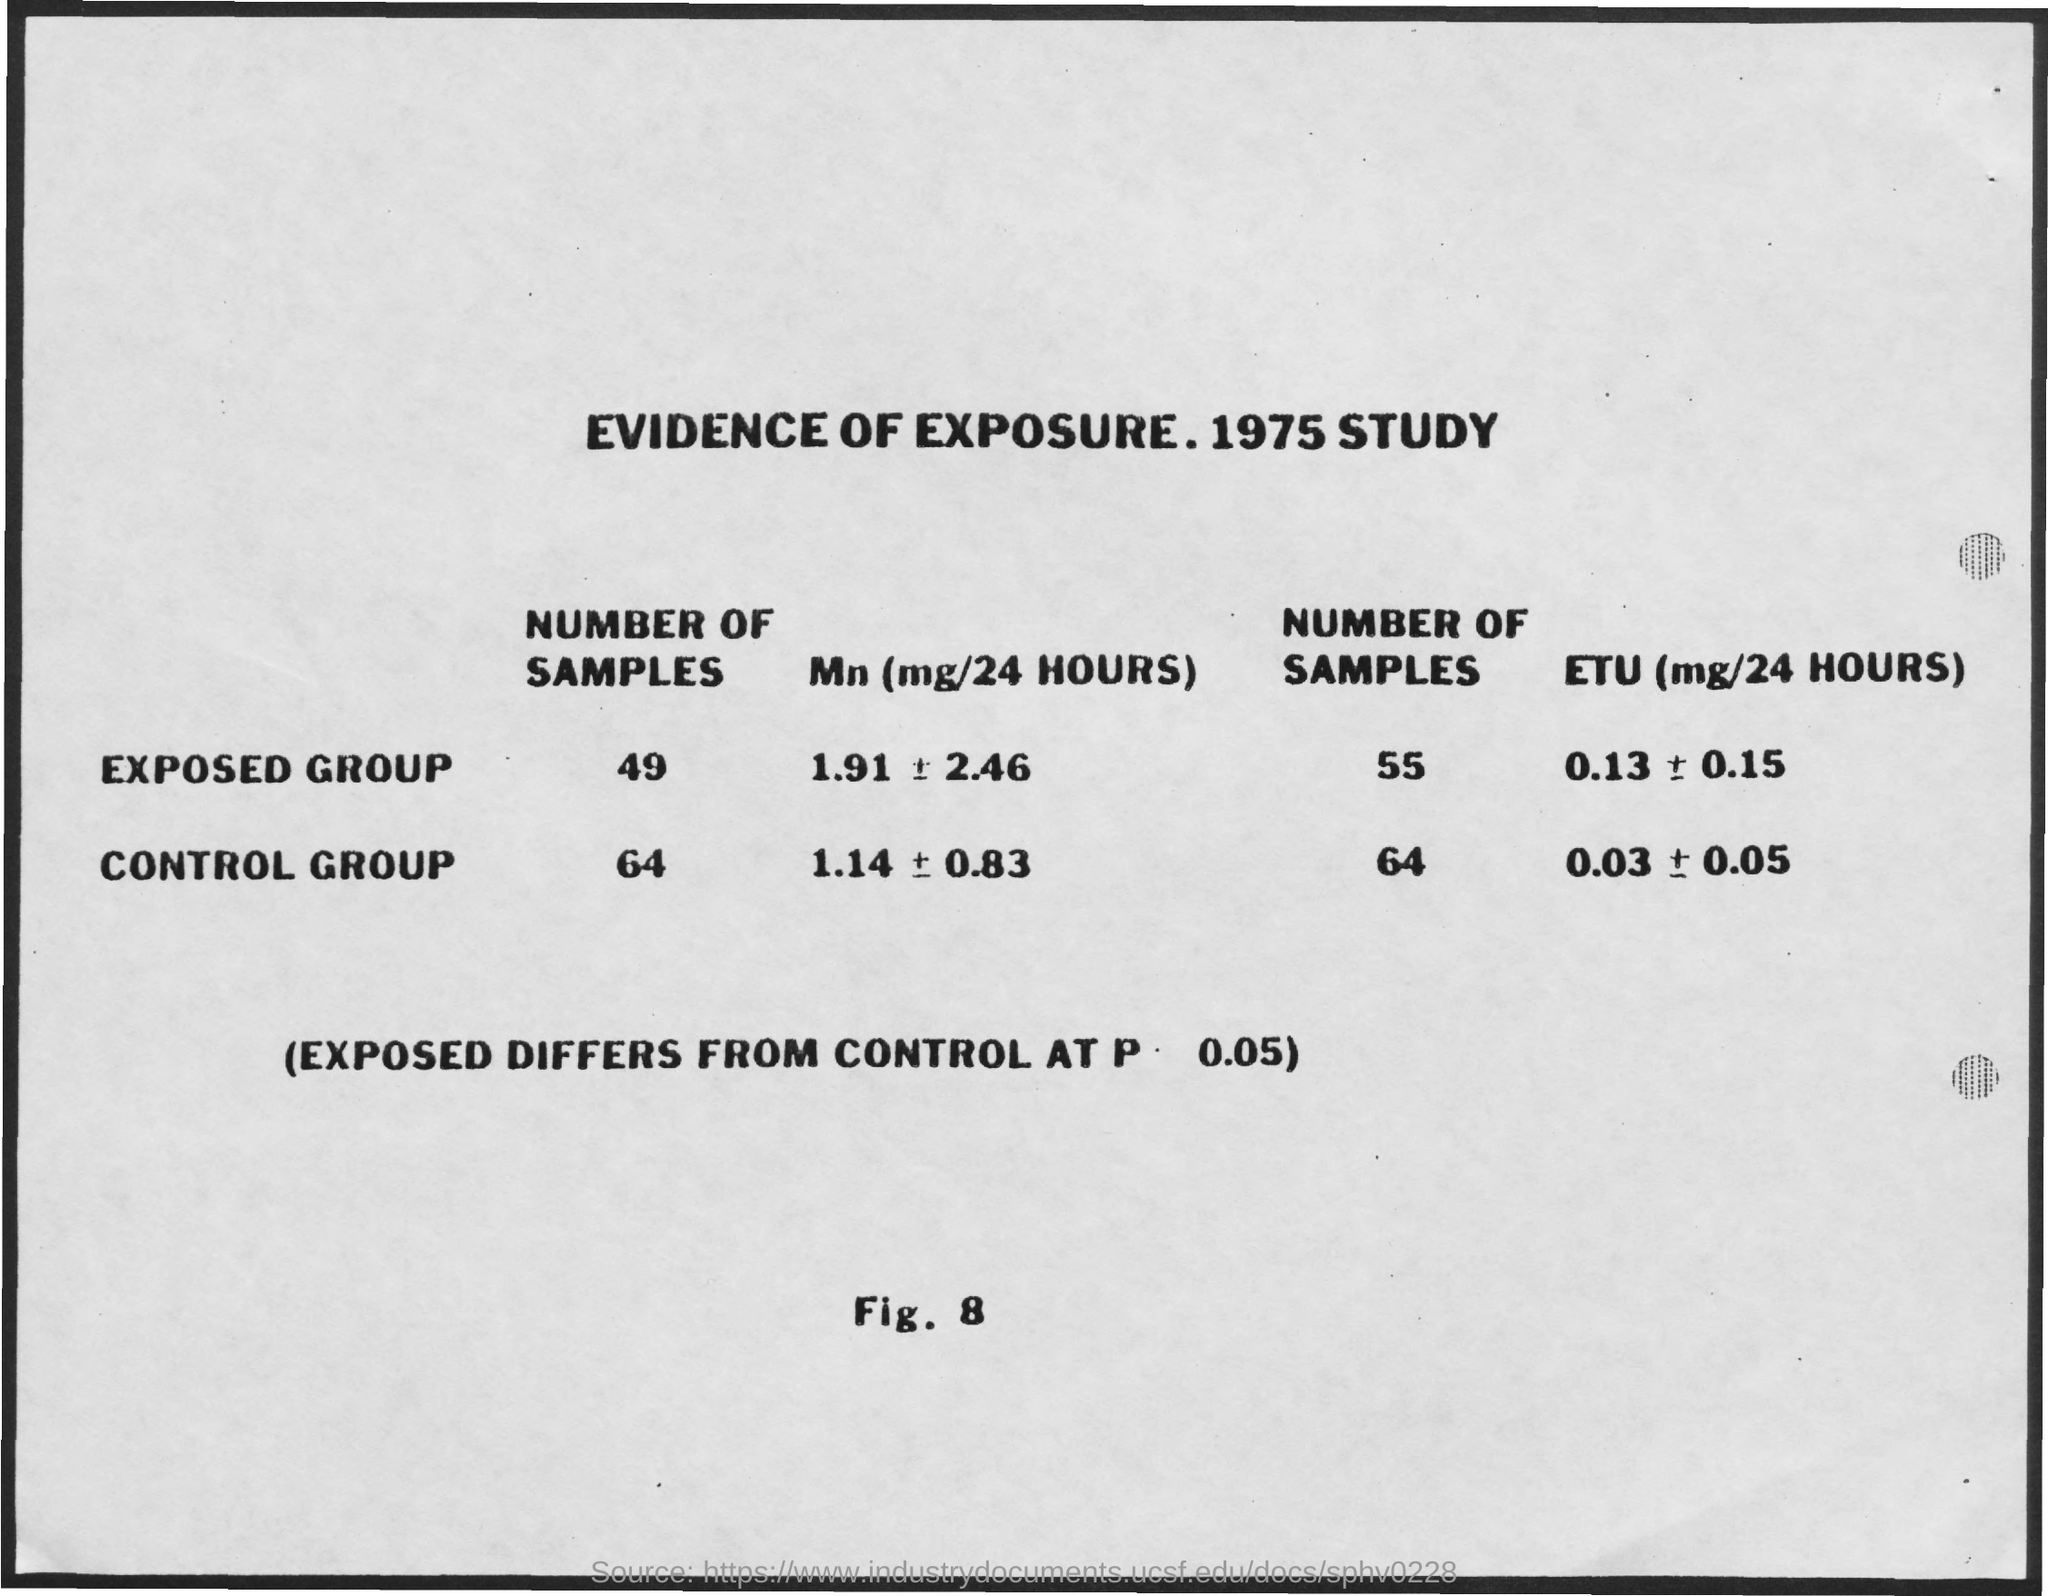List a handful of essential elements in this visual. The title of the page is 'Evidence of Exposure. 1975 Study..'. 